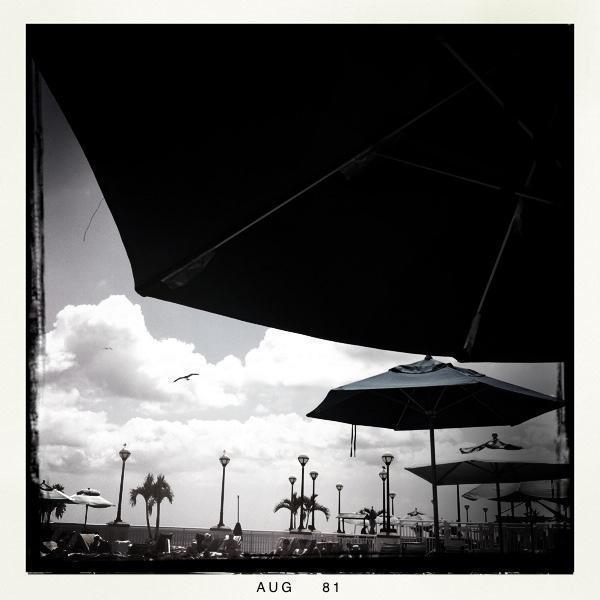Which US state is most likely to contain palm trees like the ones contained in this image?
Indicate the correct response and explain using: 'Answer: answer
Rationale: rationale.'
Options: Florida, maine, pennsylvania, new york. Answer: florida.
Rationale: Florida has a warm temperature most of the year. 